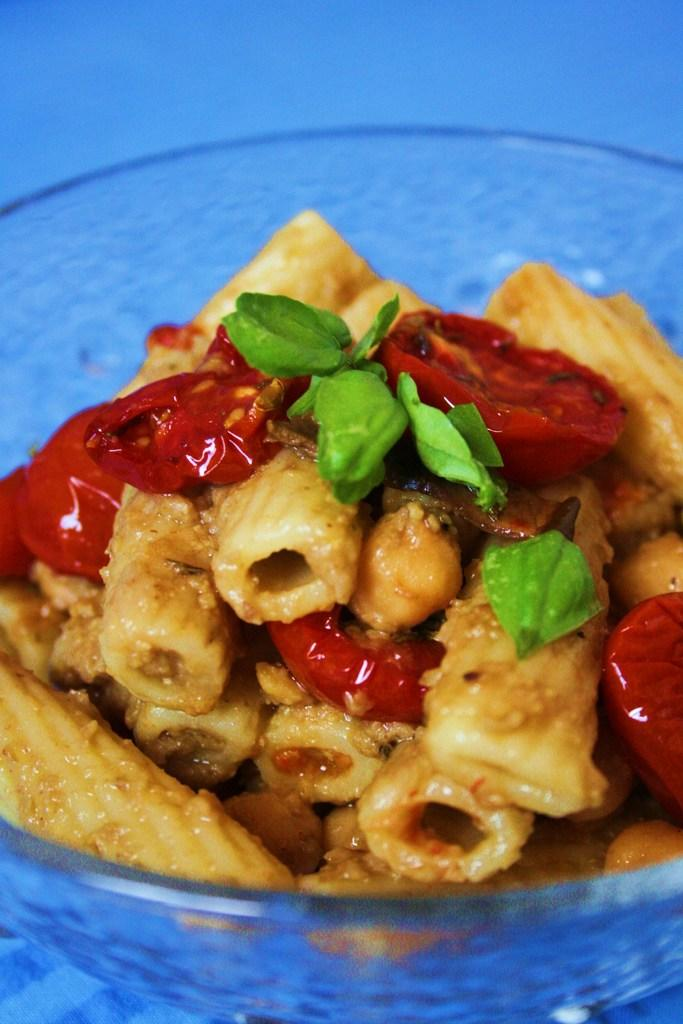What is in the bowl that is visible in the image? There is a food item in a bowl in the image. What is the bowl resting on in the image? The bowl is on an object in the image. What type of snow can be seen in the image? There is no snow present in the image. What country is the image taken in? The provided facts do not give any information about the country where the image was taken. 